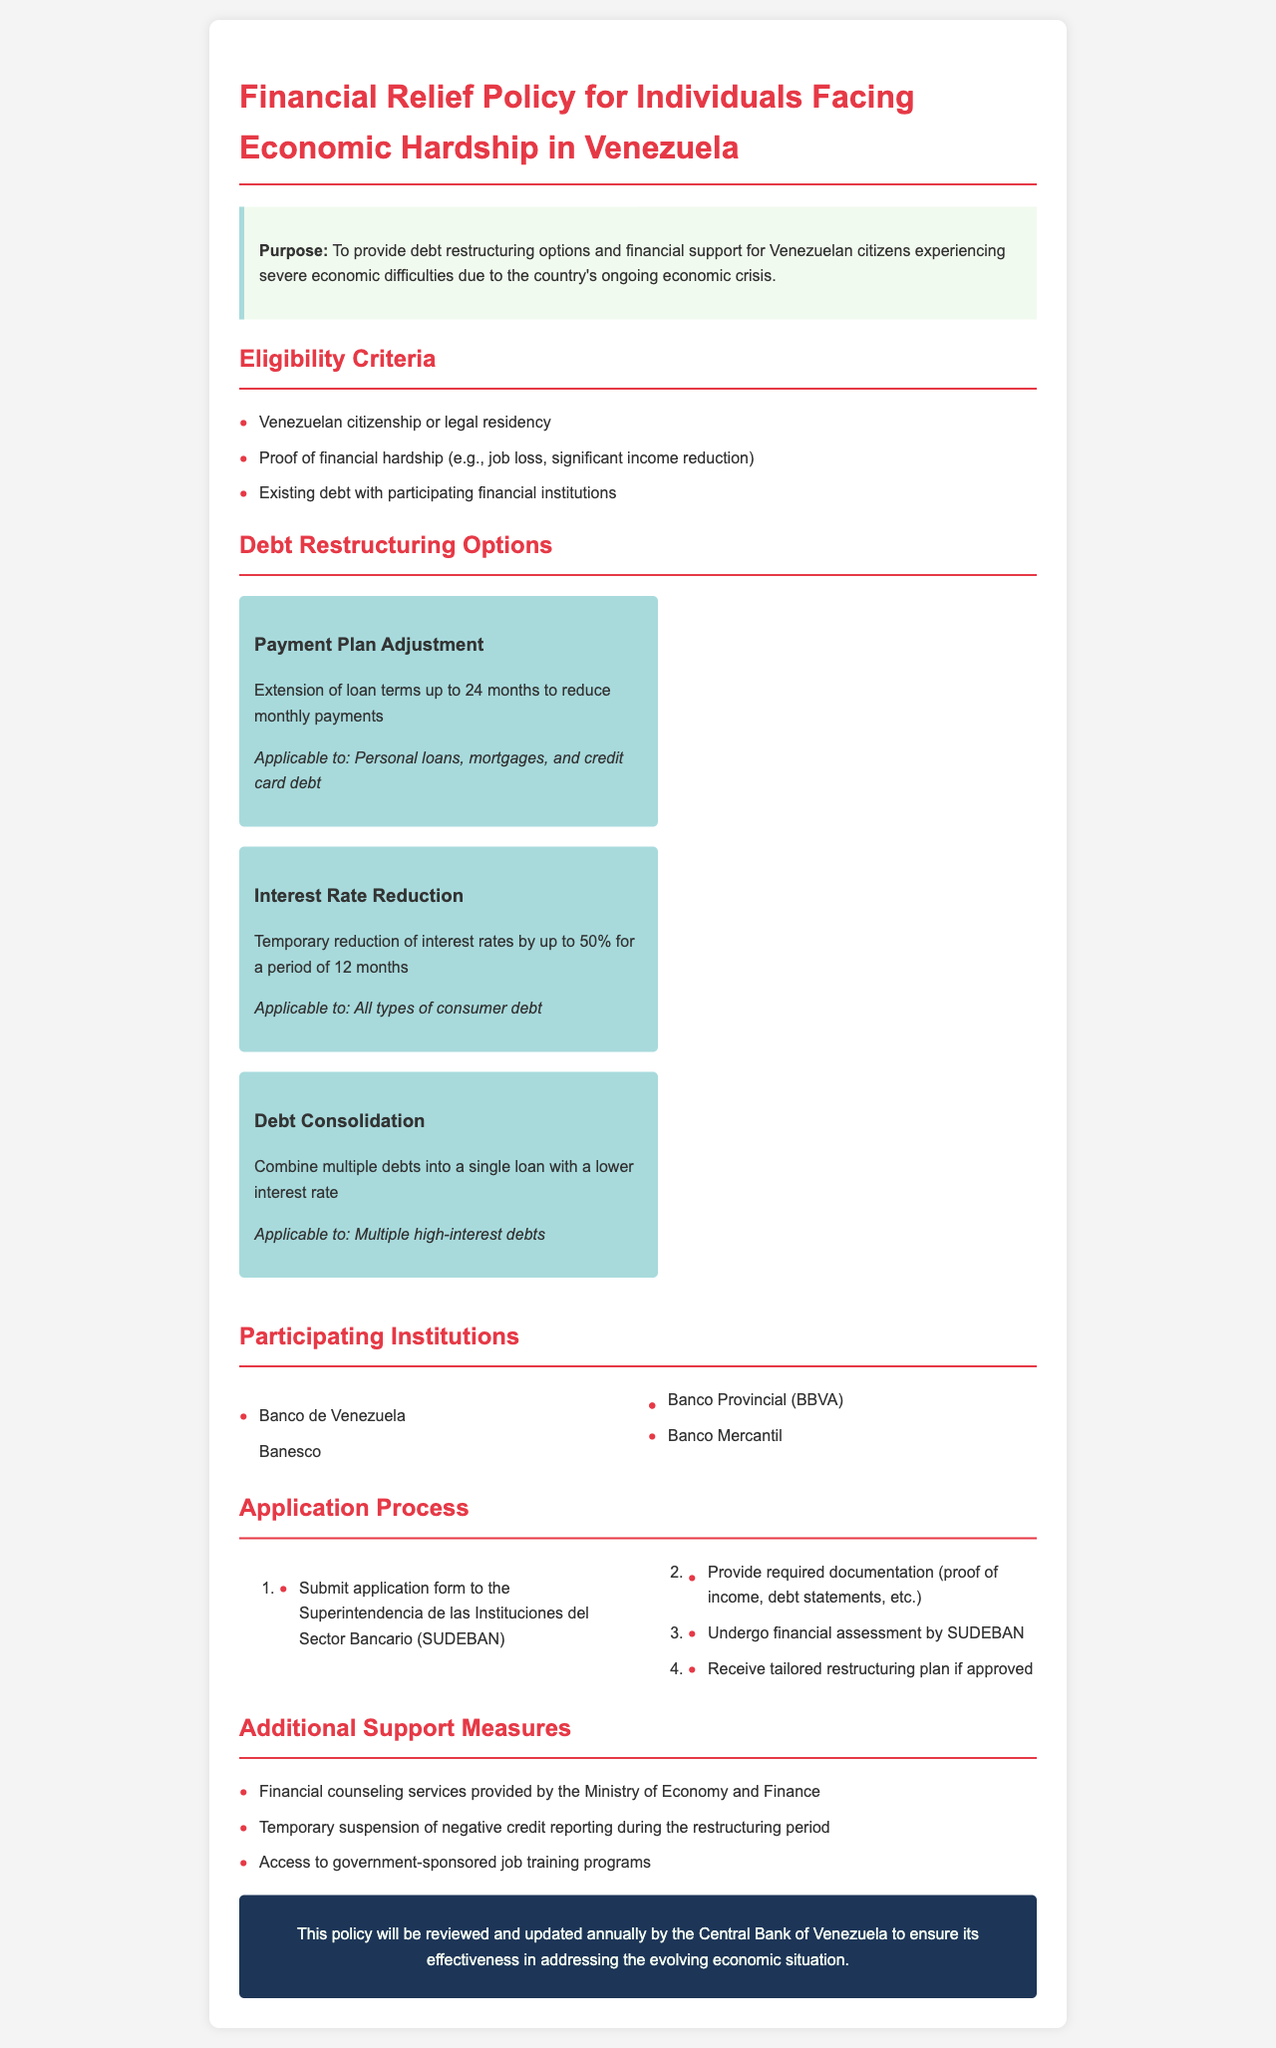What is the purpose of the policy? The purpose is to provide debt restructuring options and financial support for Venezuelan citizens experiencing severe economic difficulties due to the country's ongoing economic crisis.
Answer: To provide debt restructuring options and financial support for Venezuelan citizens experiencing severe economic difficulties due to the country's ongoing economic crisis What is the maximum extension period for loan terms? The document states that loan terms can be extended up to 24 months to reduce monthly payments.
Answer: 24 months What is the maximum interest rate reduction percentage? The policy mentions a temporary reduction of interest rates by up to 50% for a period of 12 months.
Answer: 50% Which institution is mentioned first in the list of participating institutions? The first institution mentioned in the list of participating institutions is Banco de Venezuela.
Answer: Banco de Venezuela What is the first step in the application process? The document outlines that the first step is to submit the application form to the Superintendencia de las Instituciones del Sector Bancario (SUDEBAN).
Answer: Submit application form to the Superintendencia de las Instituciones del Sector Bancario (SUDEBAN) How long is the period for which the interest rate can be reduced? The document states that the interest rate can be temporarily reduced for a period of 12 months.
Answer: 12 months What type of debt does the debt consolidation option apply to? The option for debt consolidation applies to multiple high-interest debts.
Answer: Multiple high-interest debts What additional support measure is provided during the restructuring period? The document highlights that there is a temporary suspension of negative credit reporting during the restructuring period.
Answer: Temporary suspension of negative credit reporting during the restructuring period 